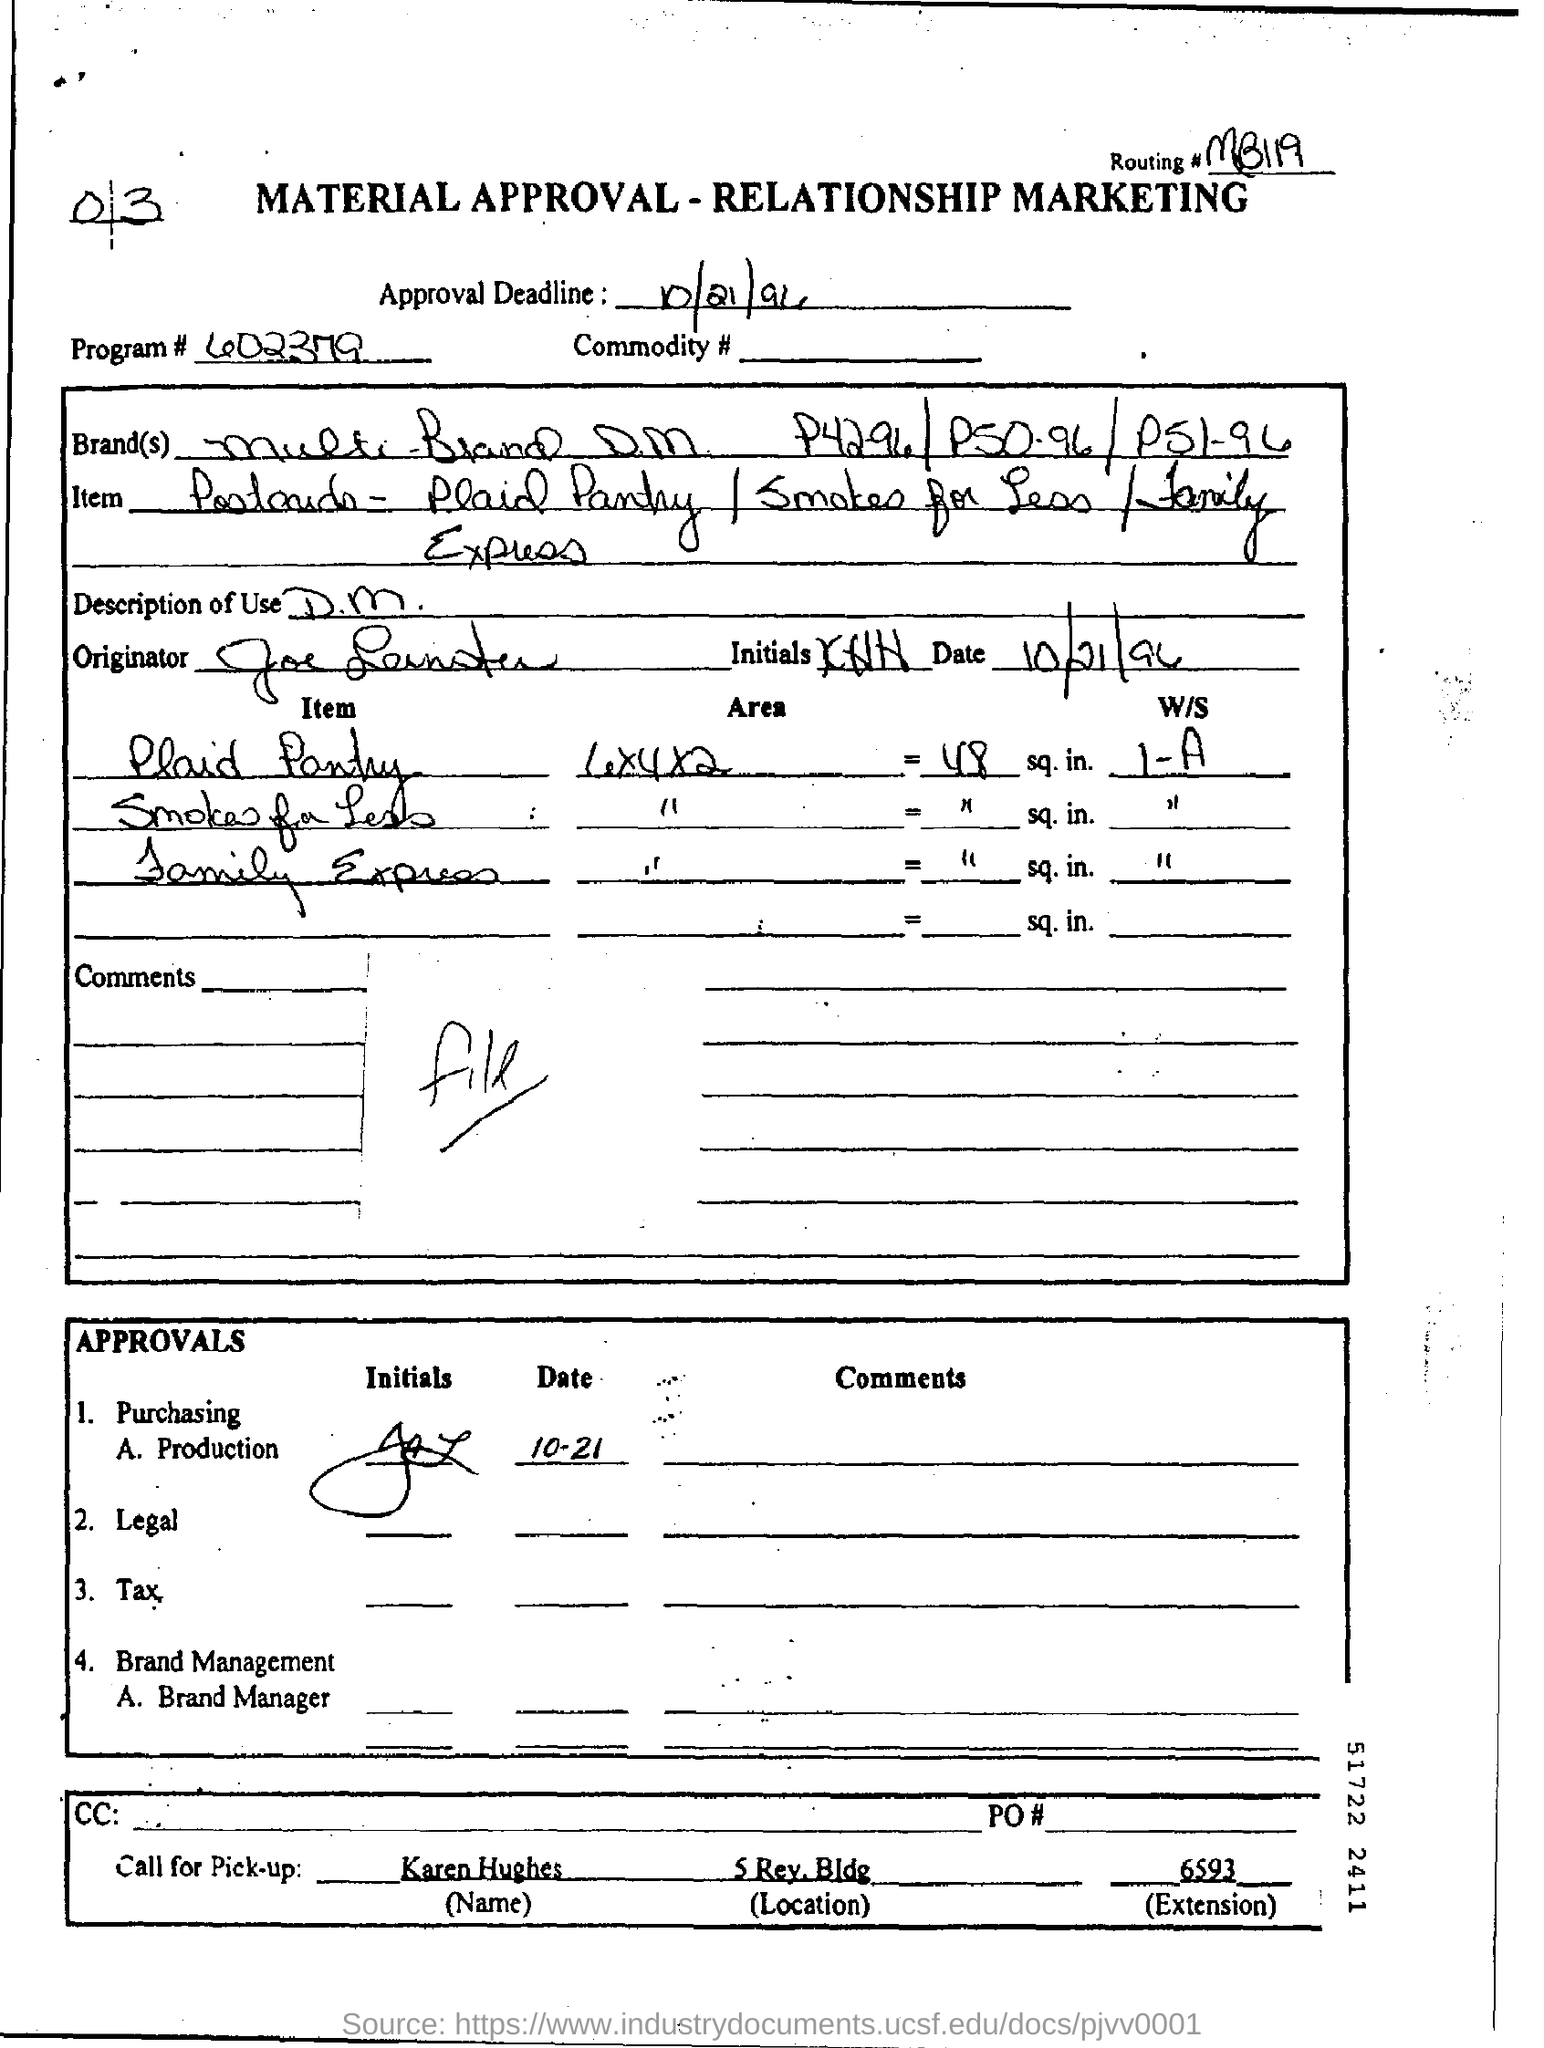What is the Routing # ?
Offer a very short reply. MB119. What is the Program #?
Keep it short and to the point. 602379. When is the Approval Deadline?
Give a very brief answer. 10/21/96. What is the "Call for Pick-Up" "Name" ?
Your response must be concise. Karen hughes. 